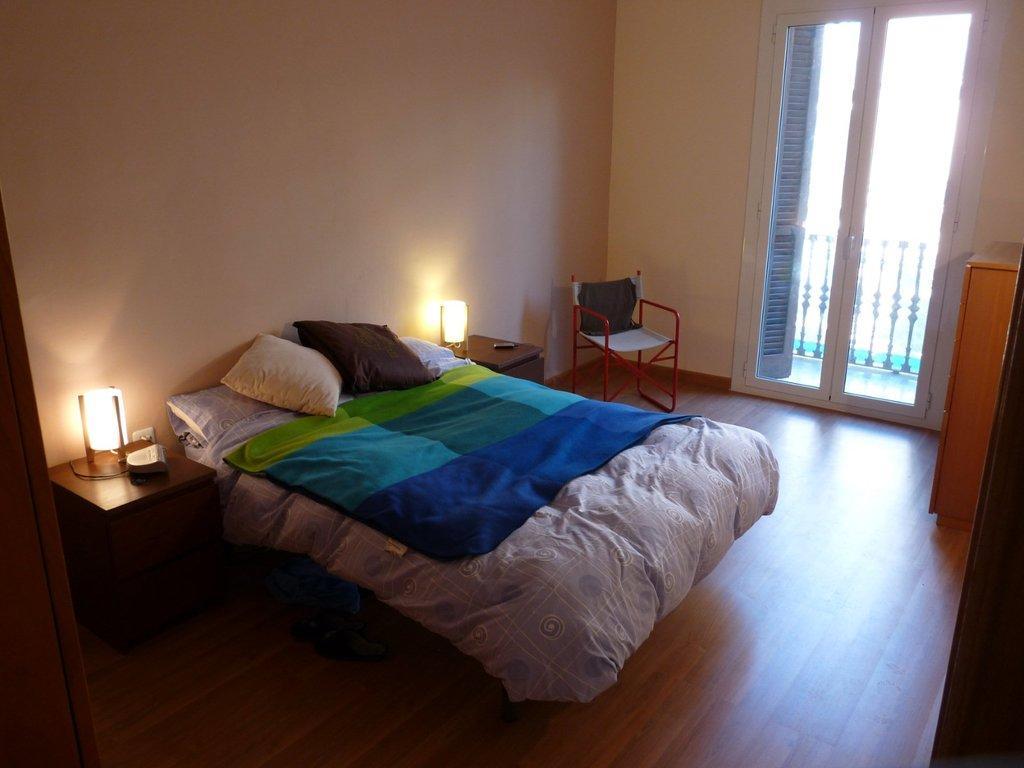How would you summarize this image in a sentence or two? In this room there is a bed covered with a blanket and a pillows and a chair. There is a lamp stand. There are shoes on the floor. At the background there is a window-glass and a wall. 